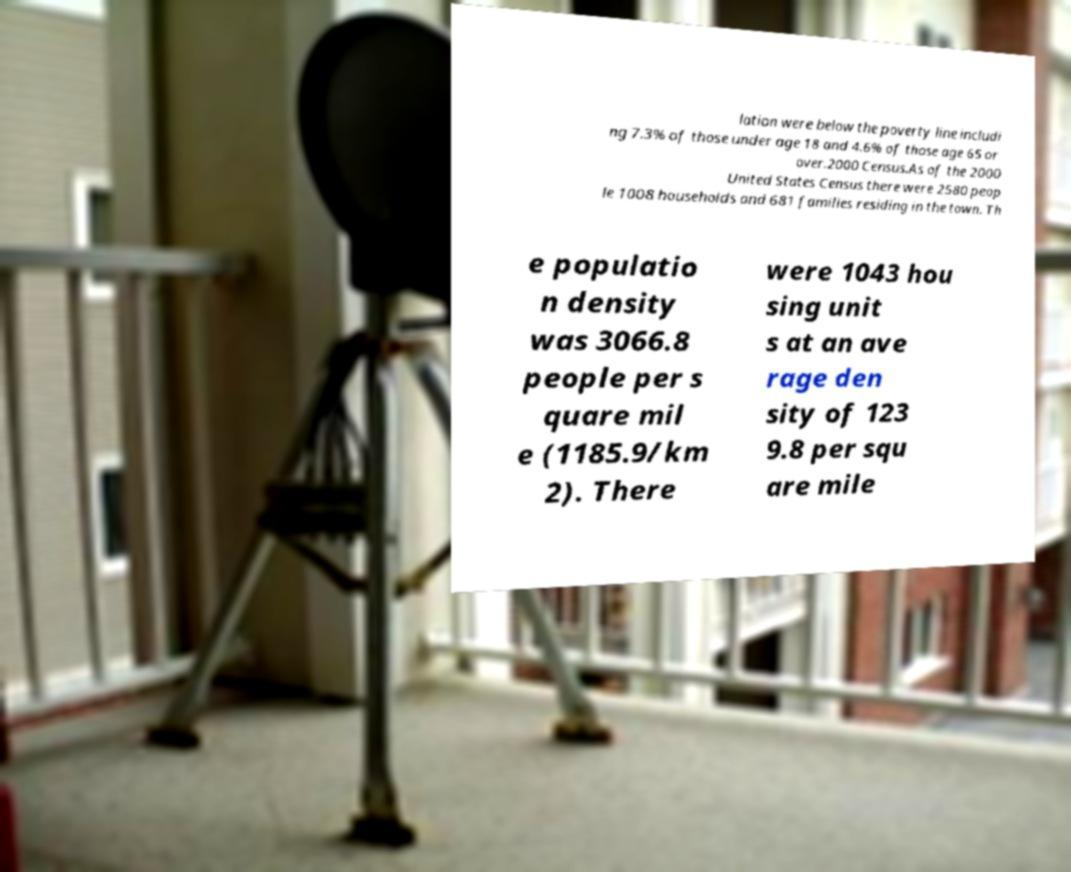What messages or text are displayed in this image? I need them in a readable, typed format. lation were below the poverty line includi ng 7.3% of those under age 18 and 4.6% of those age 65 or over.2000 Census.As of the 2000 United States Census there were 2580 peop le 1008 households and 681 families residing in the town. Th e populatio n density was 3066.8 people per s quare mil e (1185.9/km 2). There were 1043 hou sing unit s at an ave rage den sity of 123 9.8 per squ are mile 